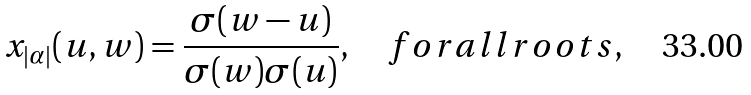<formula> <loc_0><loc_0><loc_500><loc_500>x _ { | \alpha | } ( u , w ) = { \frac { \sigma ( w - u ) } { \sigma ( w ) \sigma ( u ) } } , \quad f o r a l l r o o t s ,</formula> 